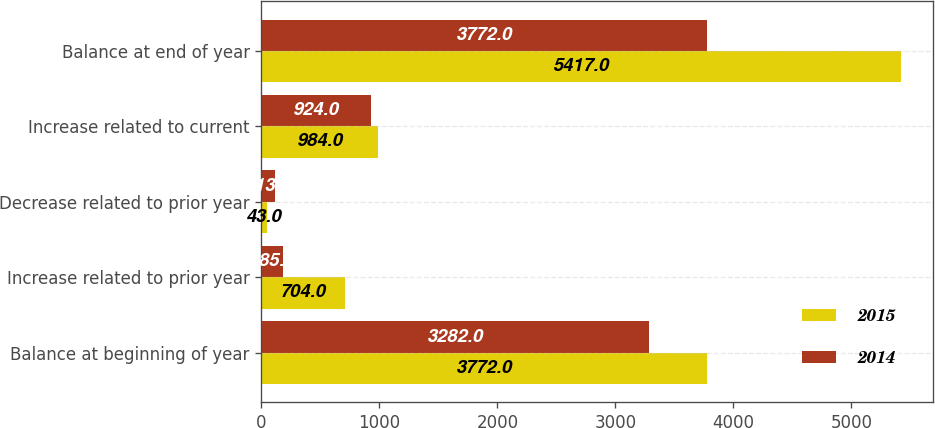Convert chart to OTSL. <chart><loc_0><loc_0><loc_500><loc_500><stacked_bar_chart><ecel><fcel>Balance at beginning of year<fcel>Increase related to prior year<fcel>Decrease related to prior year<fcel>Increase related to current<fcel>Balance at end of year<nl><fcel>2015<fcel>3772<fcel>704<fcel>43<fcel>984<fcel>5417<nl><fcel>2014<fcel>3282<fcel>185<fcel>113<fcel>924<fcel>3772<nl></chart> 